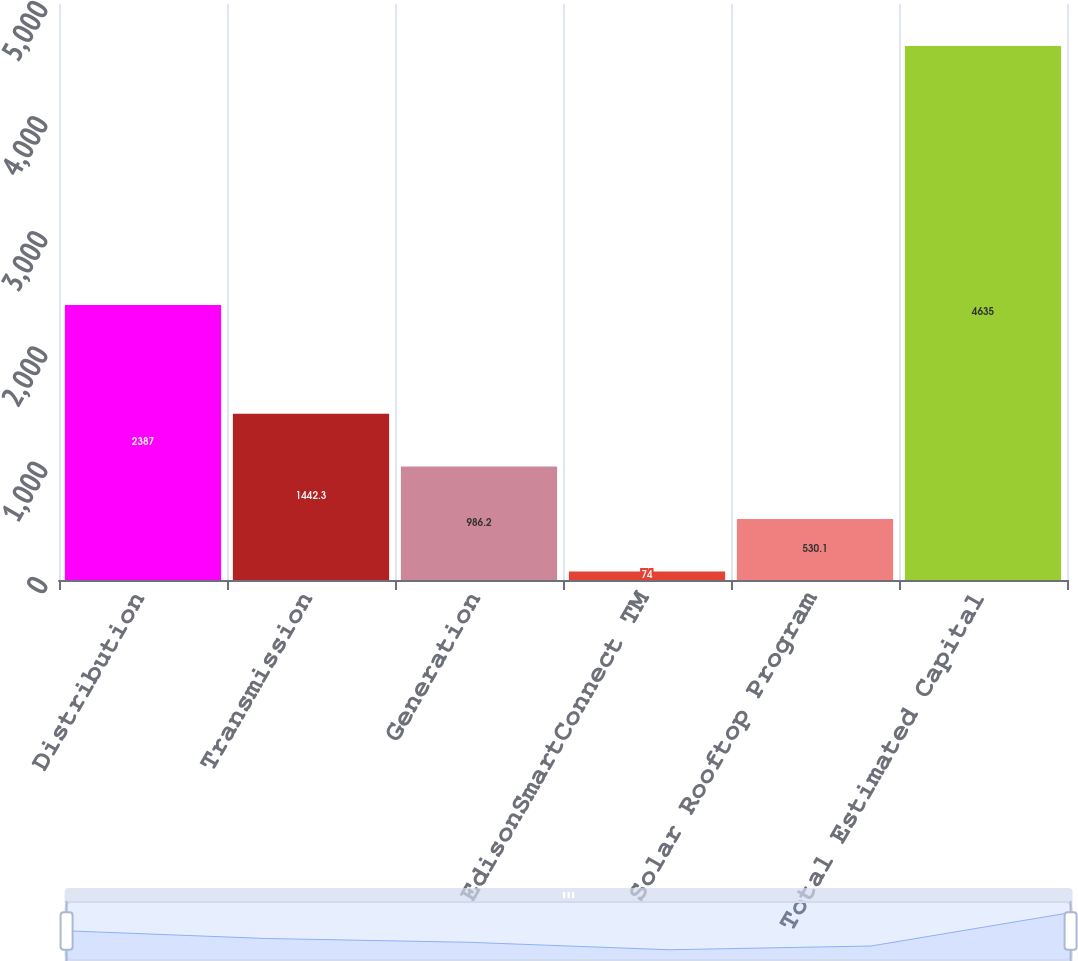Convert chart to OTSL. <chart><loc_0><loc_0><loc_500><loc_500><bar_chart><fcel>Distribution<fcel>Transmission<fcel>Generation<fcel>EdisonSmartConnect TM<fcel>Solar Rooftop Program<fcel>Total Estimated Capital<nl><fcel>2387<fcel>1442.3<fcel>986.2<fcel>74<fcel>530.1<fcel>4635<nl></chart> 